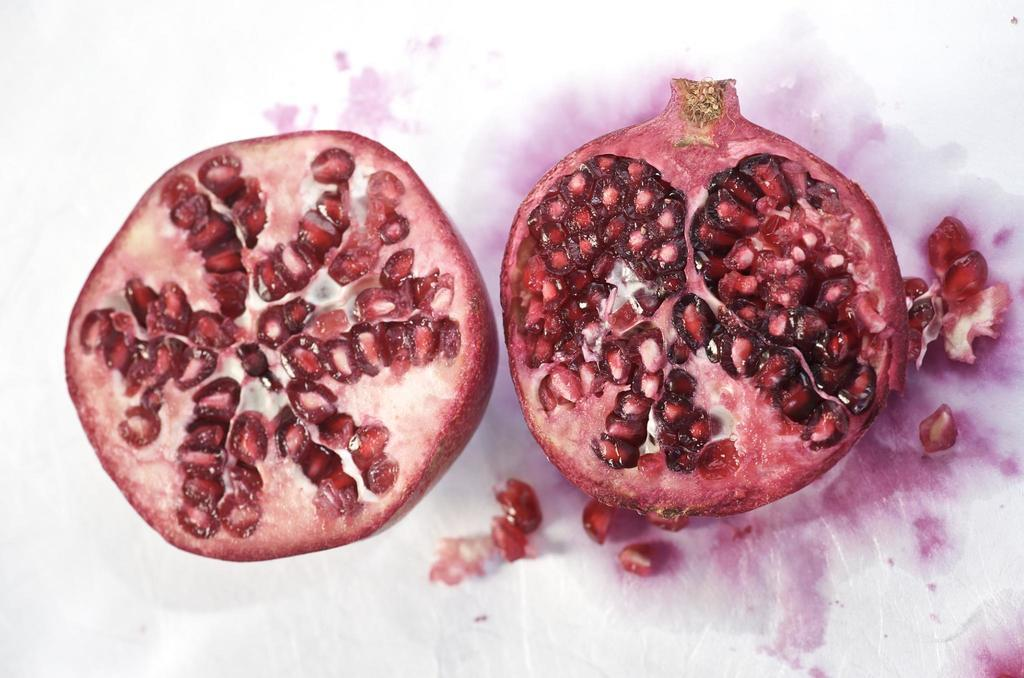What type of fruit is shown in the image? There are two pieces of a pomegranate in the image. What can be seen on the surface where the pomegranate pieces are placed? There are seeds visible on a white colored surface in the image. What type of stitch is used to sew the bedroom curtains in the image? There is no bedroom or curtains present in the image; it only features two pieces of a pomegranate and seeds on a white surface. 